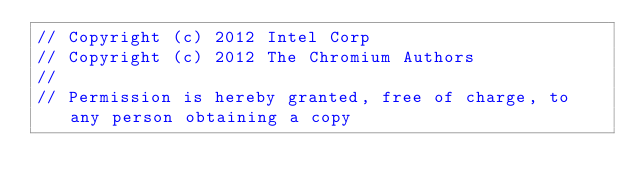Convert code to text. <code><loc_0><loc_0><loc_500><loc_500><_ObjectiveC_>// Copyright (c) 2012 Intel Corp
// Copyright (c) 2012 The Chromium Authors
//
// Permission is hereby granted, free of charge, to any person obtaining a copy</code> 